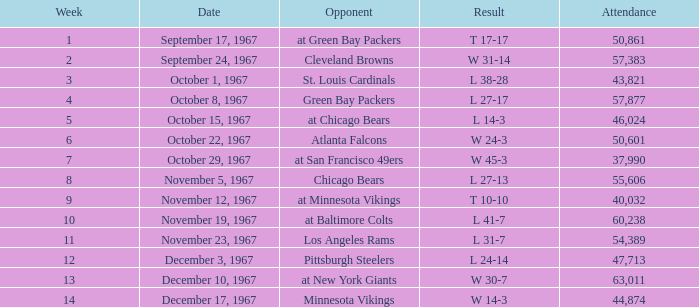How many weeks have a Result of t 10-10? 1.0. 